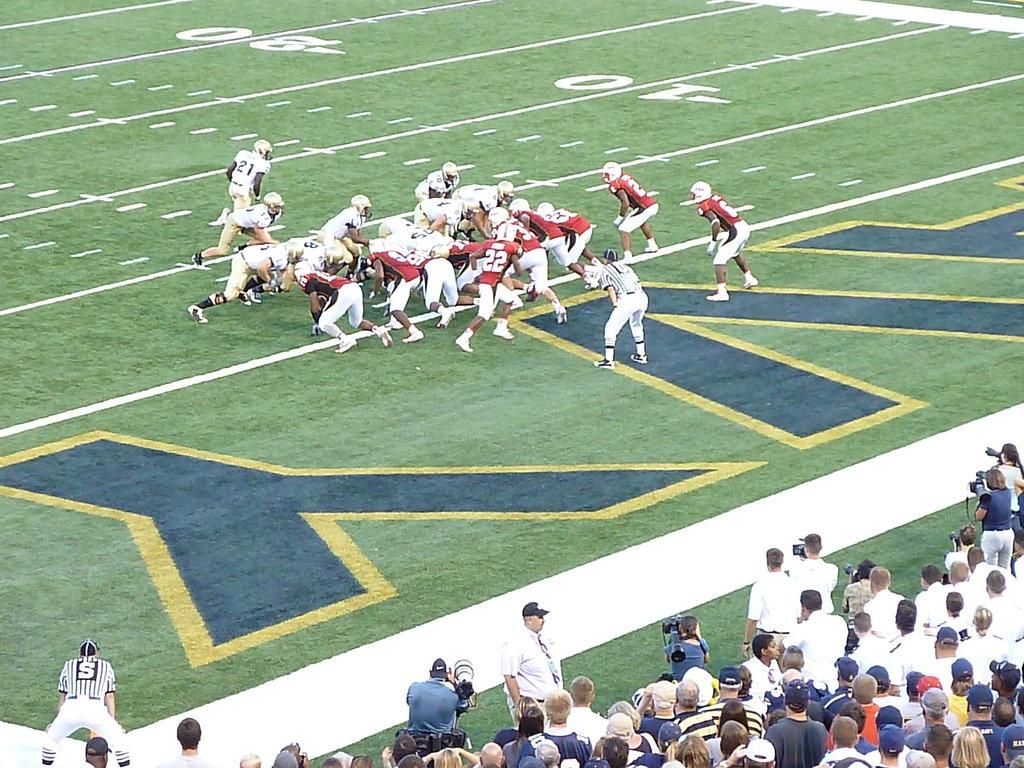Where was the image taken? The image was taken in a stadium. What activity is taking place in the image? There are people playing a game on the ground. Are there any observers in the image? Yes, there are spectators standing nearby. What can be seen written on the ground? There is text visible on the ground. How many apples can be seen in the hands of the girl in the image? There is no girl or apples present in the image. What organization is responsible for the game being played in the image? The image does not provide information about the organization responsible for the game. 